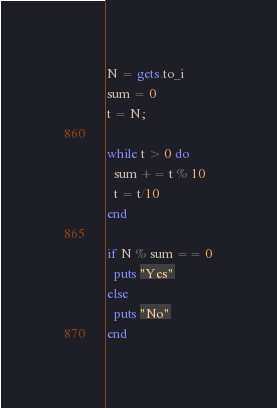Convert code to text. <code><loc_0><loc_0><loc_500><loc_500><_Ruby_>N = gets.to_i
sum = 0
t = N;

while t > 0 do
  sum += t % 10
  t = t/10
end

if N % sum == 0
  puts "Yes"
else
  puts "No"
end</code> 